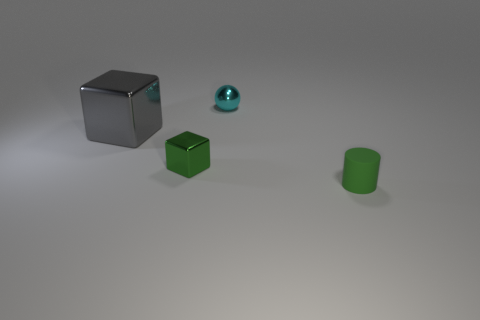What materials are the objects made from in the image? The objects in the image appear to be made from various materials. The large cube on the left looks like it could be a gray metal, the smaller cube is possibly plastic with a matte finish, and the sphere seems to have a reflective surface, perhaps made of glass or polished metal. The cylinder also appears to be made out of a matte material similar to plastic. 